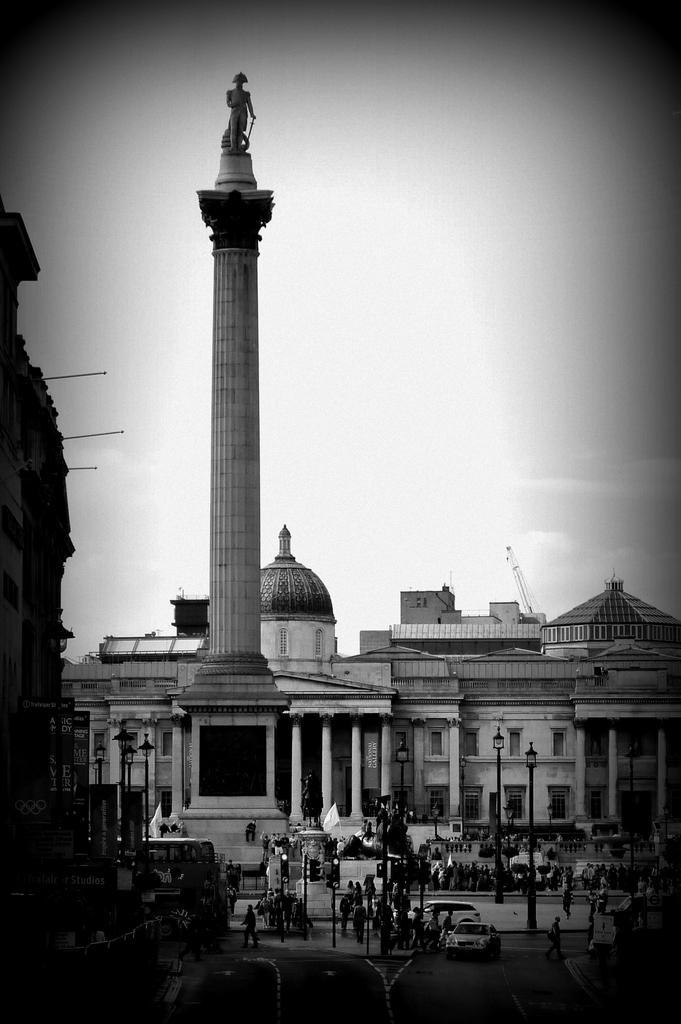Describe this image in one or two sentences. In this picture we can observe a pillar on which there is a statue. There are some poles and a building on which we can observe a dome. In the background there is a sky. This is a black and white image. 